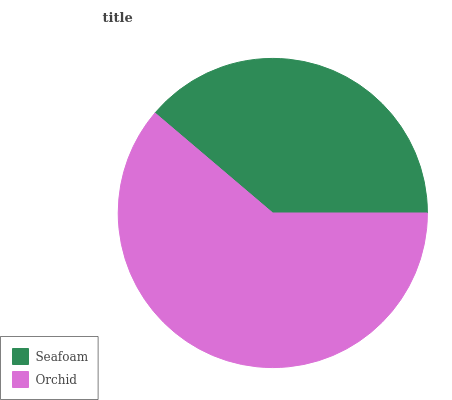Is Seafoam the minimum?
Answer yes or no. Yes. Is Orchid the maximum?
Answer yes or no. Yes. Is Orchid the minimum?
Answer yes or no. No. Is Orchid greater than Seafoam?
Answer yes or no. Yes. Is Seafoam less than Orchid?
Answer yes or no. Yes. Is Seafoam greater than Orchid?
Answer yes or no. No. Is Orchid less than Seafoam?
Answer yes or no. No. Is Orchid the high median?
Answer yes or no. Yes. Is Seafoam the low median?
Answer yes or no. Yes. Is Seafoam the high median?
Answer yes or no. No. Is Orchid the low median?
Answer yes or no. No. 